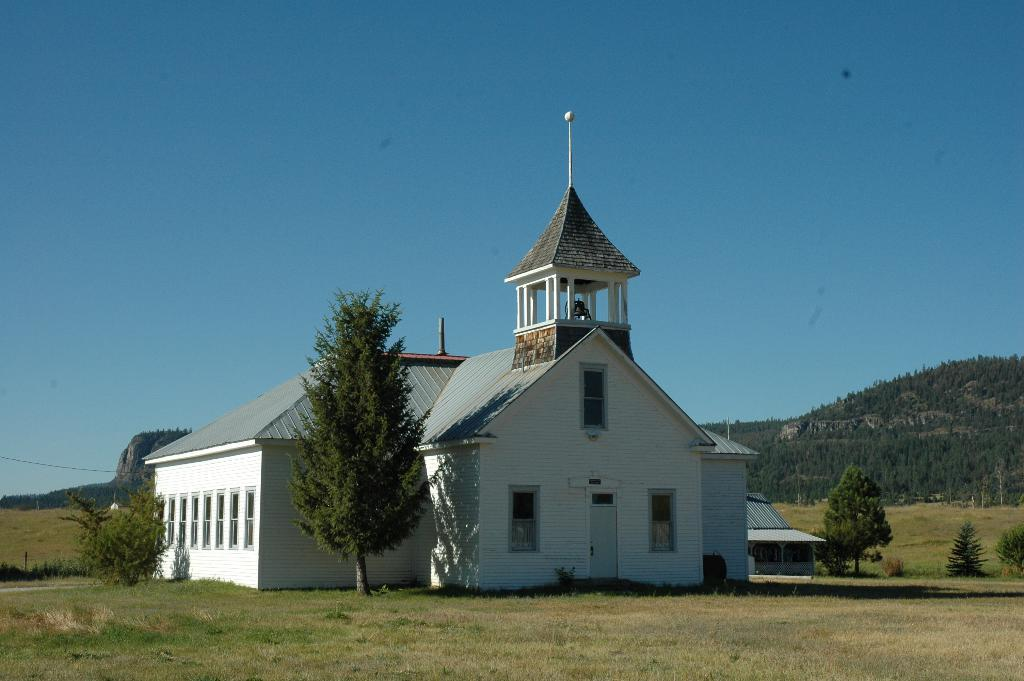What type of structure is present in the image? There is a house in the image. What can be seen surrounding the house? There are trees around the house. What other types of vegetation are visible in the image? There are plants in the image. What natural feature can be seen in the distance? There are mountains visible in the image. What type of crime is being committed in the image? There is no indication of any crime being committed in the image. What is the process of constructing the roof of the house in the image? The image does not show the construction process of the house's roof. 